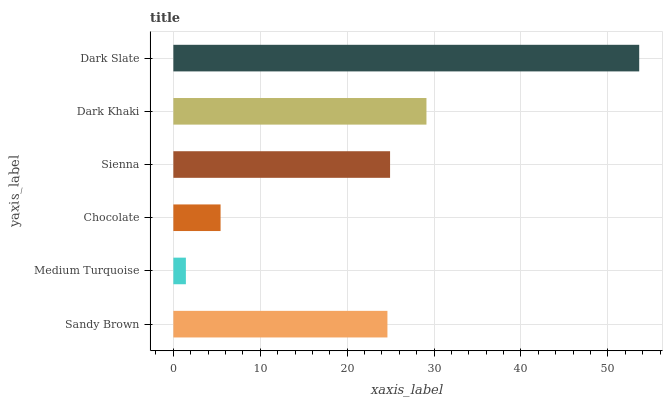Is Medium Turquoise the minimum?
Answer yes or no. Yes. Is Dark Slate the maximum?
Answer yes or no. Yes. Is Chocolate the minimum?
Answer yes or no. No. Is Chocolate the maximum?
Answer yes or no. No. Is Chocolate greater than Medium Turquoise?
Answer yes or no. Yes. Is Medium Turquoise less than Chocolate?
Answer yes or no. Yes. Is Medium Turquoise greater than Chocolate?
Answer yes or no. No. Is Chocolate less than Medium Turquoise?
Answer yes or no. No. Is Sienna the high median?
Answer yes or no. Yes. Is Sandy Brown the low median?
Answer yes or no. Yes. Is Dark Khaki the high median?
Answer yes or no. No. Is Sienna the low median?
Answer yes or no. No. 